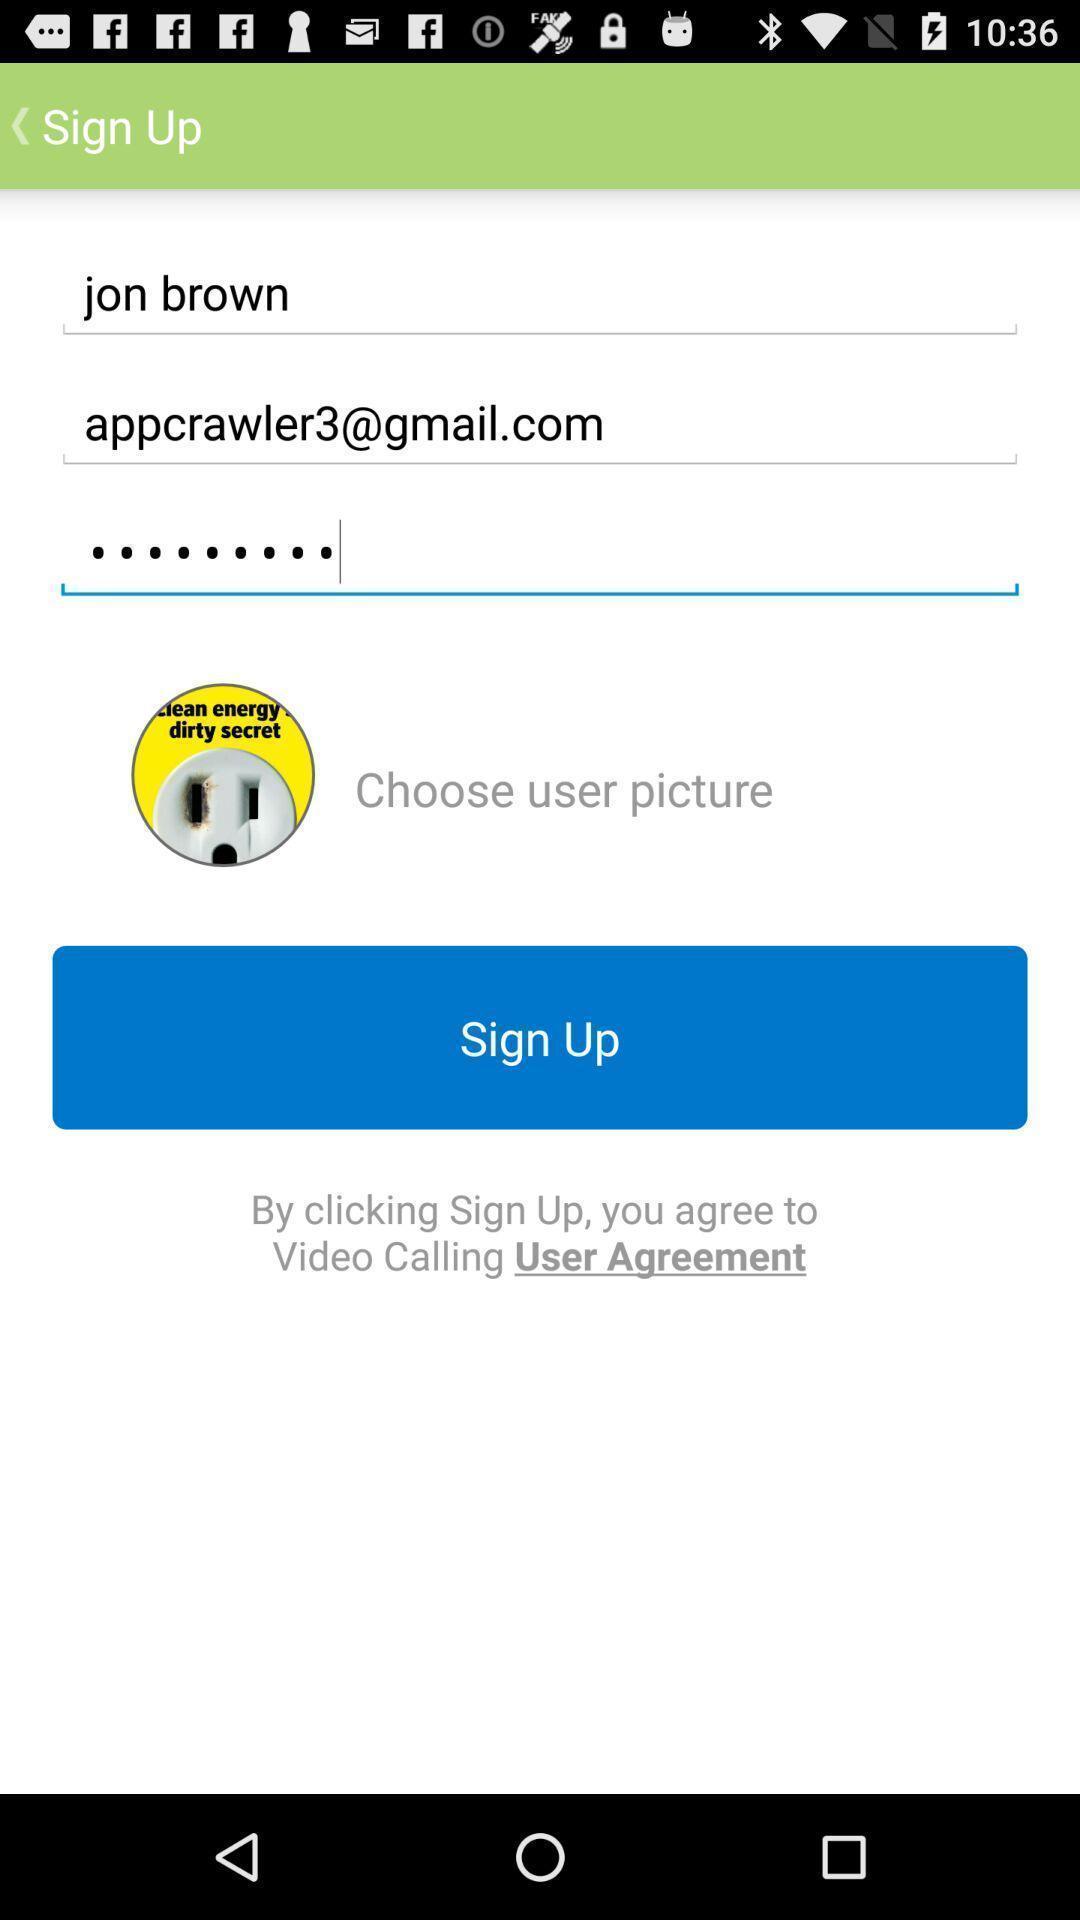Explain what's happening in this screen capture. Sign up page of the social app. 